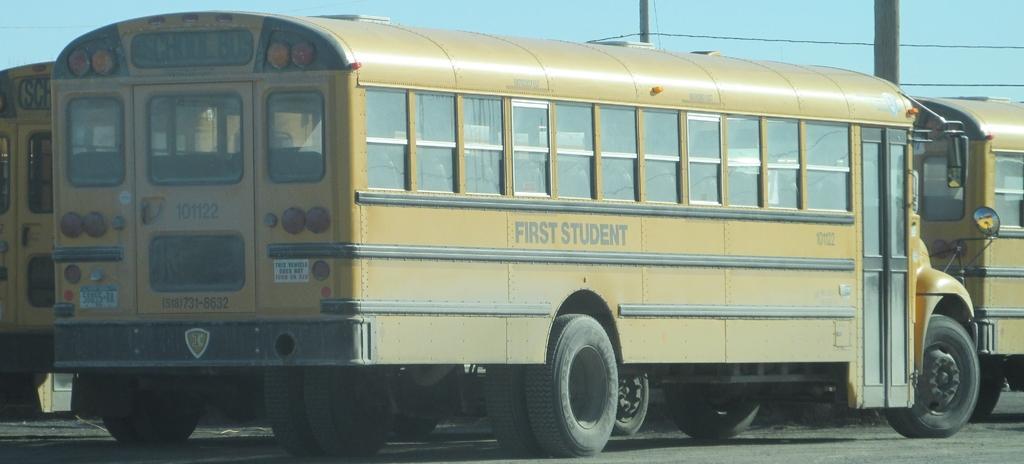Could you give a brief overview of what you see in this image? In this image there are school buses parked on the road. In the background there are poles with the wires. At the top there is the sky. 